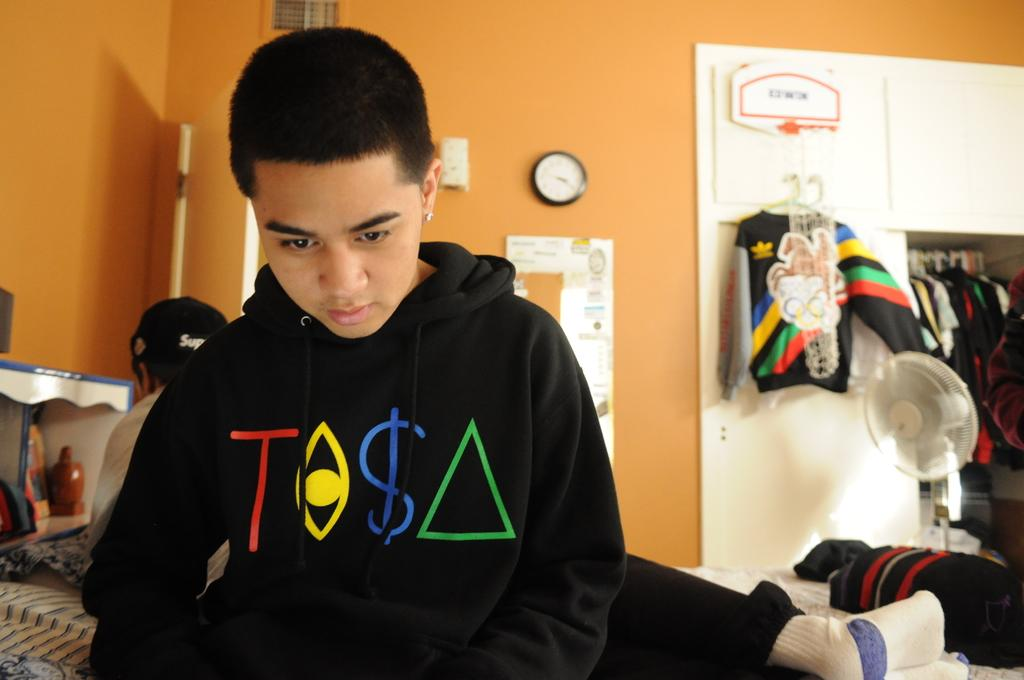<image>
Provide a brief description of the given image. Boy wearing a black hoodie that has a red letter "T" on it. 